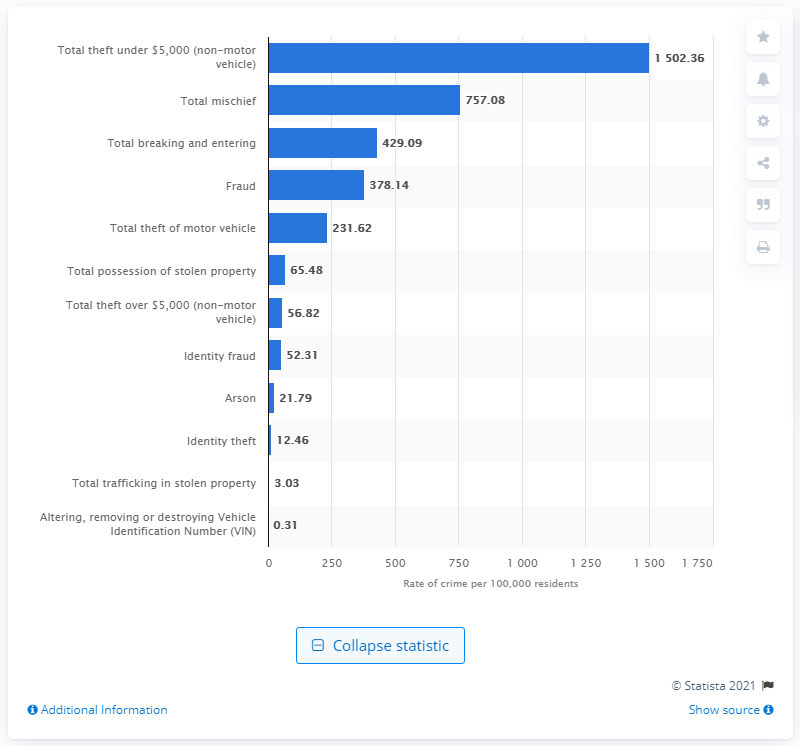What was the category with the highest reported incidents per 100,000 residents in Canada in 2019, and what was the rate? The category with the highest reported incidents per 100,000 residents in Canada in 2019 was 'Total theft under $5,000 (non-motor vehicle)', with a rate of 1,502.36 incidents. 